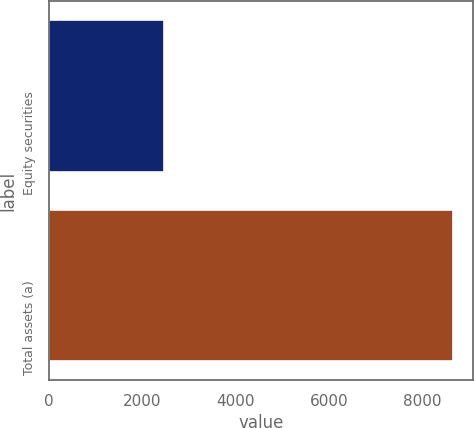Convert chart. <chart><loc_0><loc_0><loc_500><loc_500><bar_chart><fcel>Equity securities<fcel>Total assets (a)<nl><fcel>2472<fcel>8655<nl></chart> 